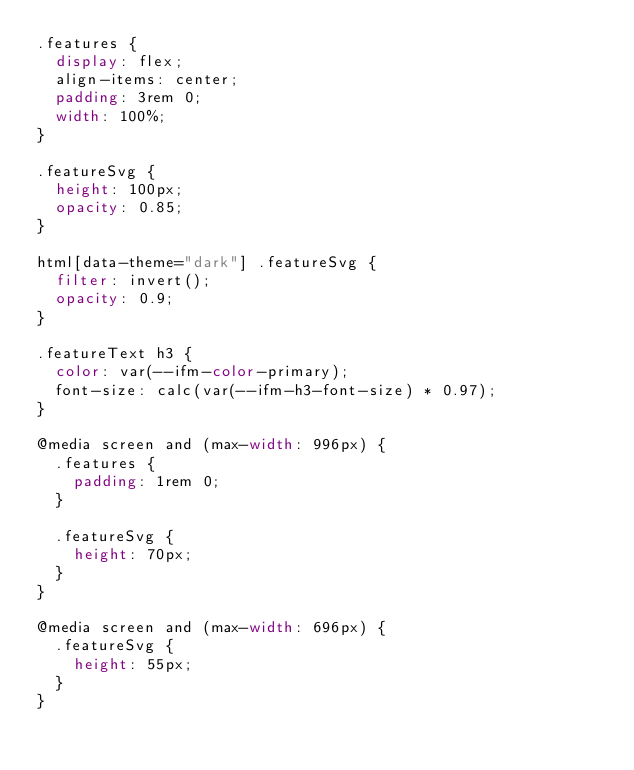Convert code to text. <code><loc_0><loc_0><loc_500><loc_500><_CSS_>.features {
  display: flex;
  align-items: center;
  padding: 3rem 0;
  width: 100%;
}

.featureSvg {
  height: 100px;
  opacity: 0.85;
}

html[data-theme="dark"] .featureSvg {
  filter: invert();
  opacity: 0.9;
}

.featureText h3 {
  color: var(--ifm-color-primary);
  font-size: calc(var(--ifm-h3-font-size) * 0.97);
}

@media screen and (max-width: 996px) {
  .features {
    padding: 1rem 0;
  }

  .featureSvg {
    height: 70px;
  }
}

@media screen and (max-width: 696px) {
  .featureSvg {
    height: 55px;
  }
}
</code> 